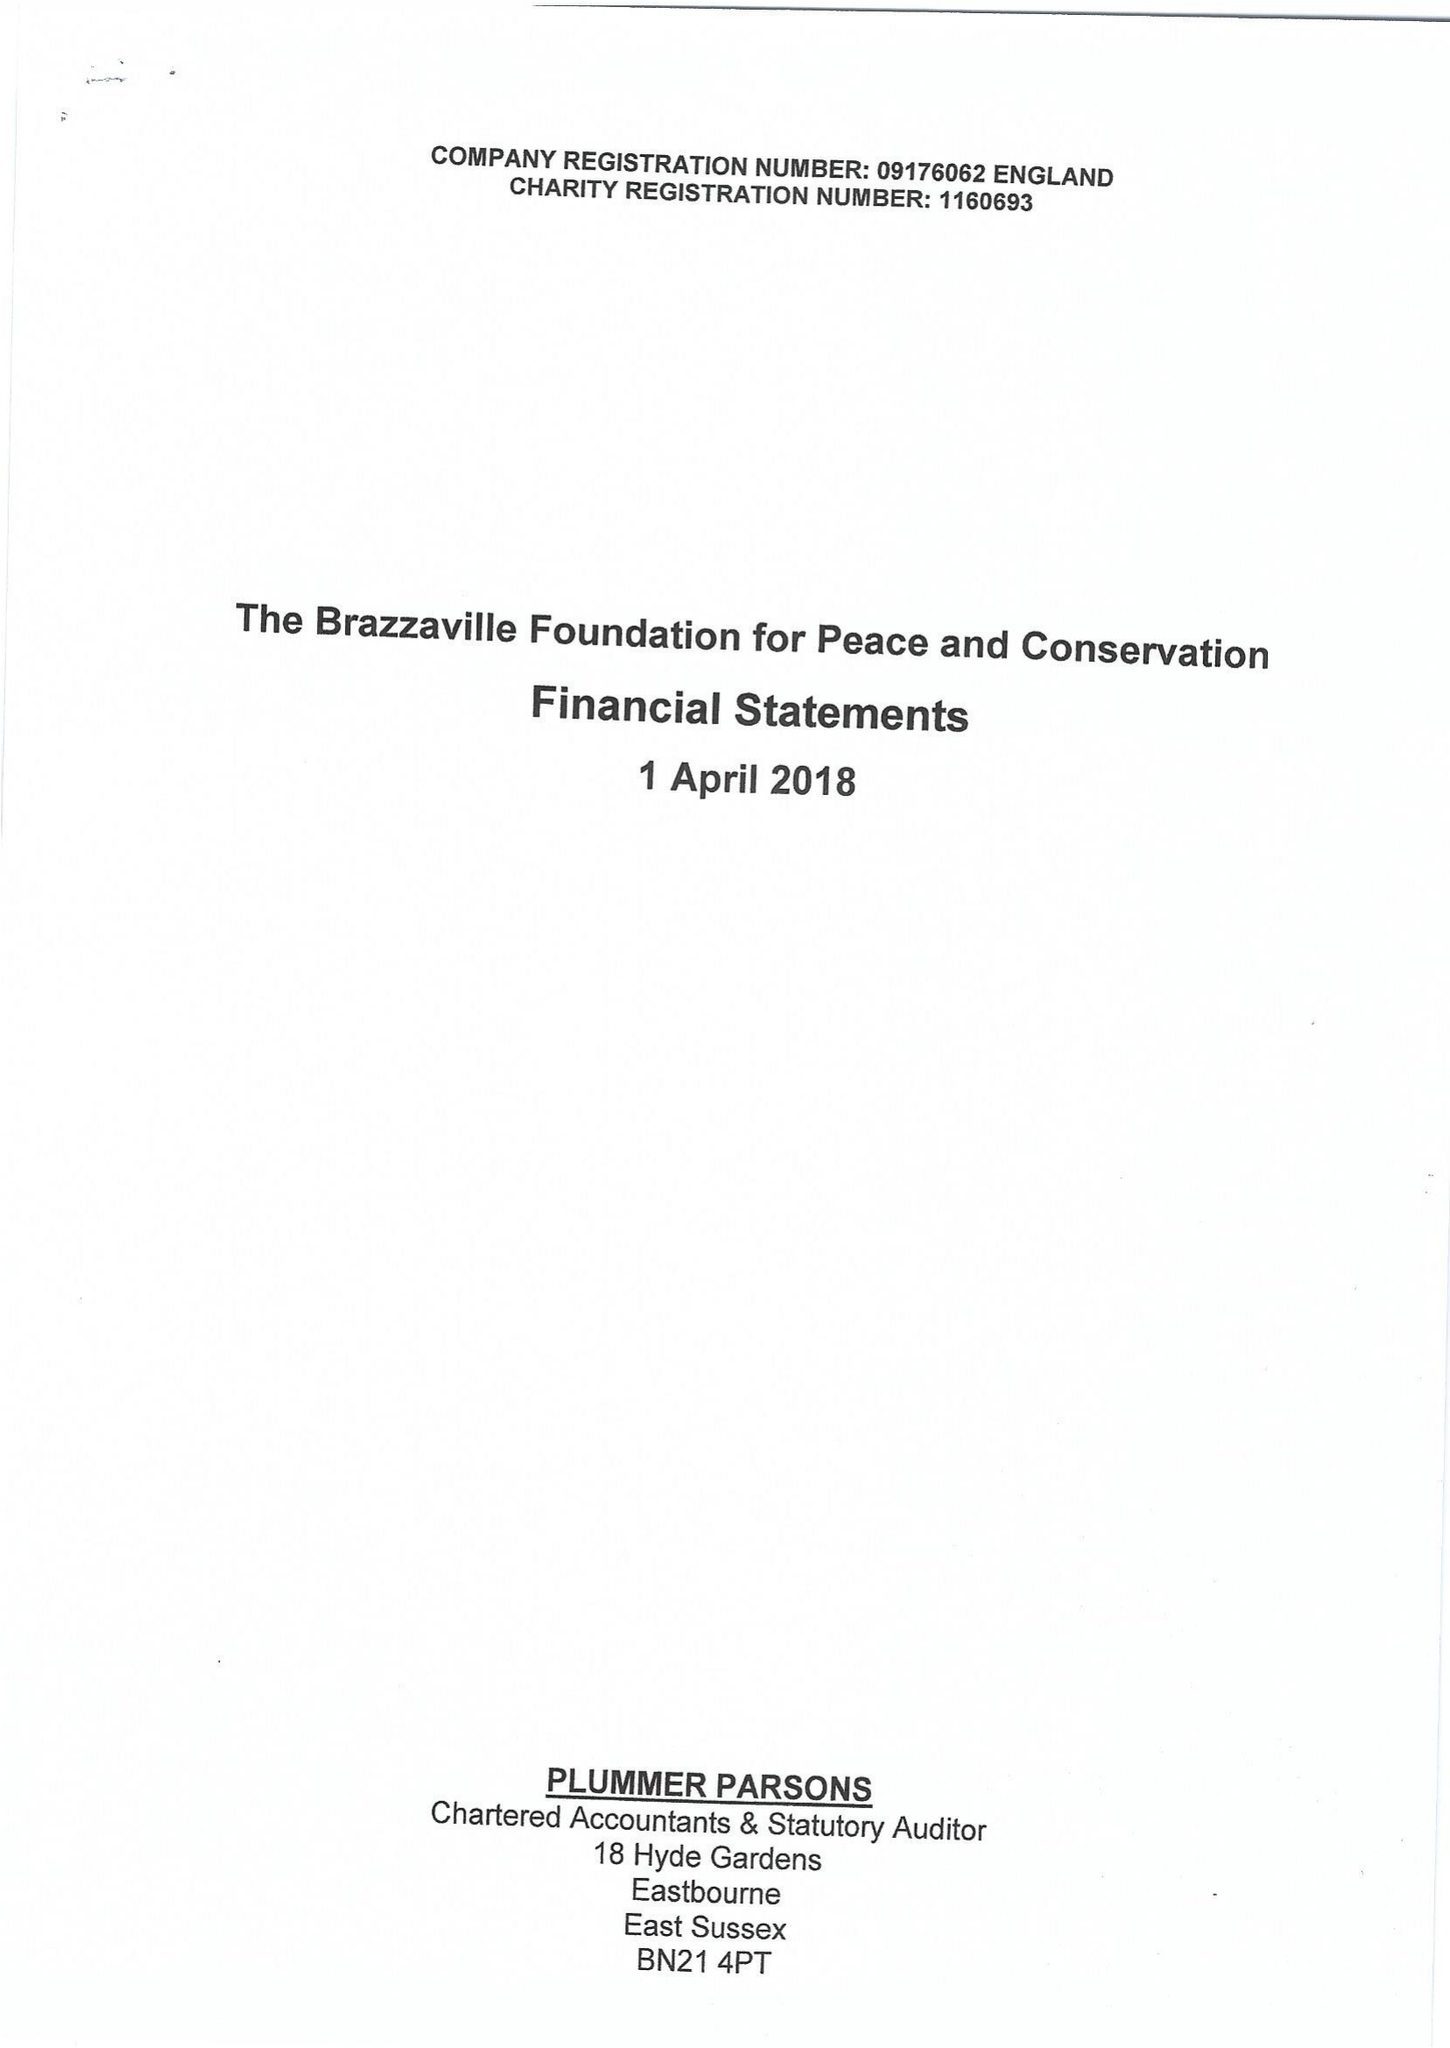What is the value for the charity_number?
Answer the question using a single word or phrase. 1160693 